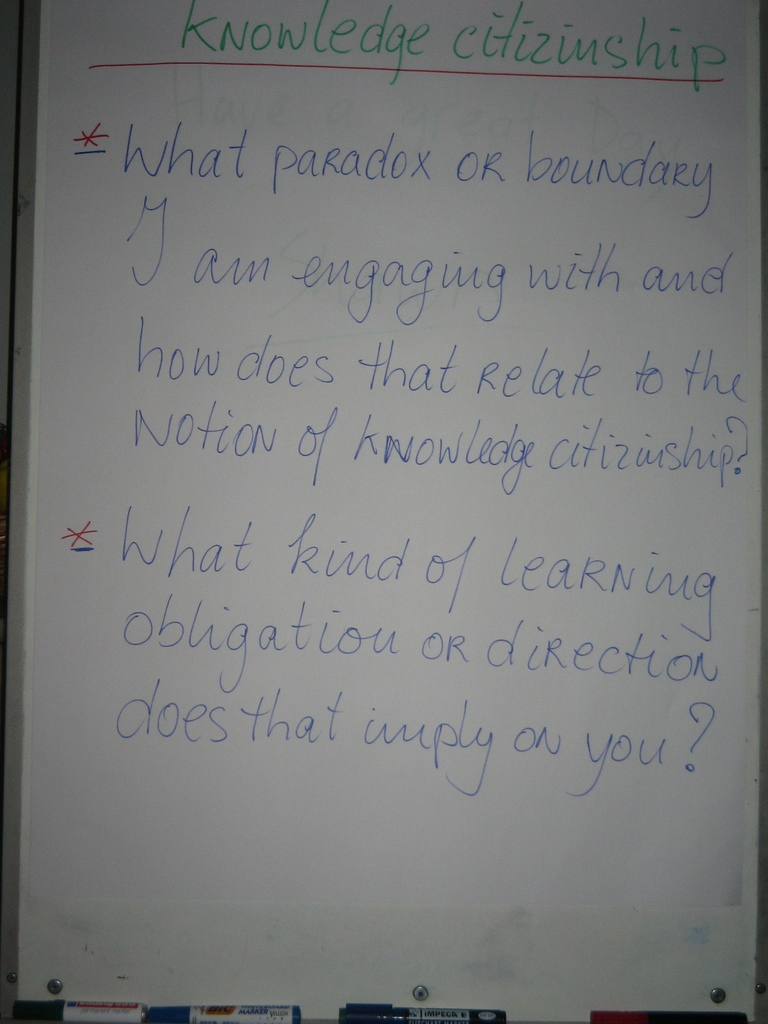What do you see happening in this image? The image shows a whiteboard with two reflective and pedagogically focused questions. At the heart of these questions is the pursuit of understanding our engagement with contradictions or limits in our thinking (paradoxes and boundaries) and considering our roles as 'knowledge citizens', which means being active, responsible contributors to the collective pool of human understanding. It provokes us to consider how our individual learning challenges connect to this larger educational and social responsibility, and consequently, what obligations we have to pursue certain directions in our learning to contribute meaningfully to society. 